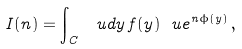<formula> <loc_0><loc_0><loc_500><loc_500>I ( n ) = \int _ { C } \, \ u d y \, f ( y ) \ u e ^ { n \phi ( y ) } \, ,</formula> 